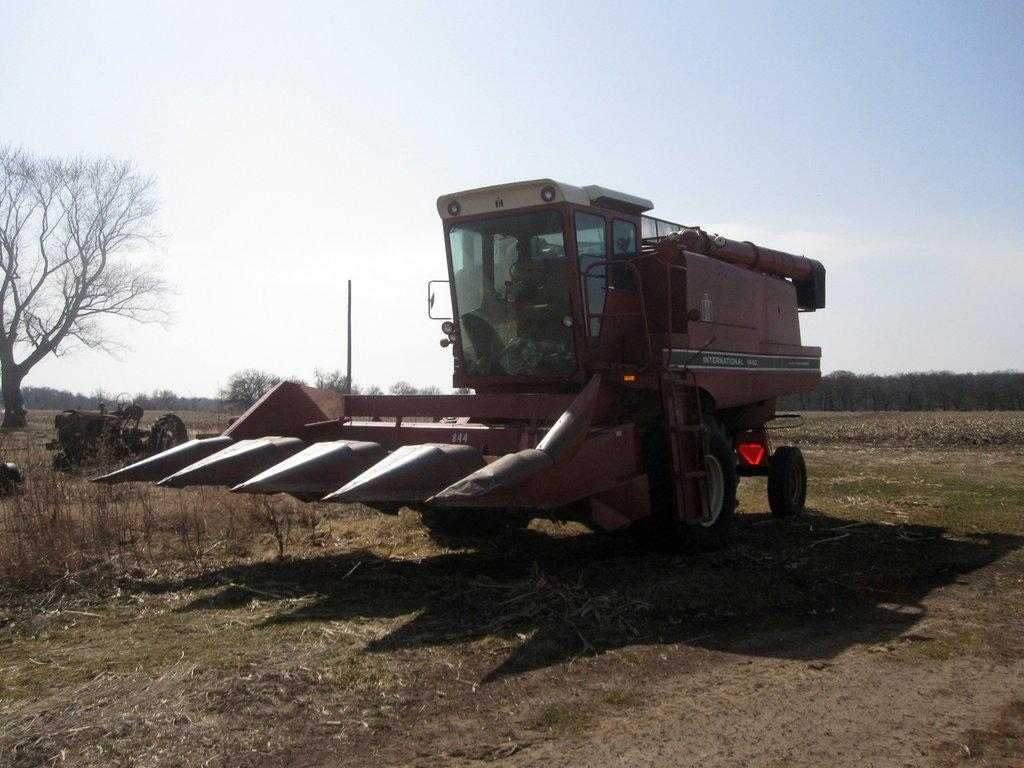What is the main subject of the image? There is a vehicle in the image. Can you describe the position of the vehicle? The vehicle is on the ground. What can be seen in the background of the image? There are trees and the sky visible in the background of the image. Reasoning: Let' Let's think step by step in order to produce the conversation. We start by identifying the main subject of the image, which is the vehicle. Next, we describe the position of the vehicle, noting that it is on the ground. Finally, we describe the background of the image, which includes trees and the sky. Absurd Question/Answer: What type of prison can be seen in the image? There is no prison present in the image; it features a vehicle on the ground with trees and the sky in the background. How many beggars are visible in the image? There are no beggars present in the image. How many beggars are visible in the image? There are no beggars present in the image. 